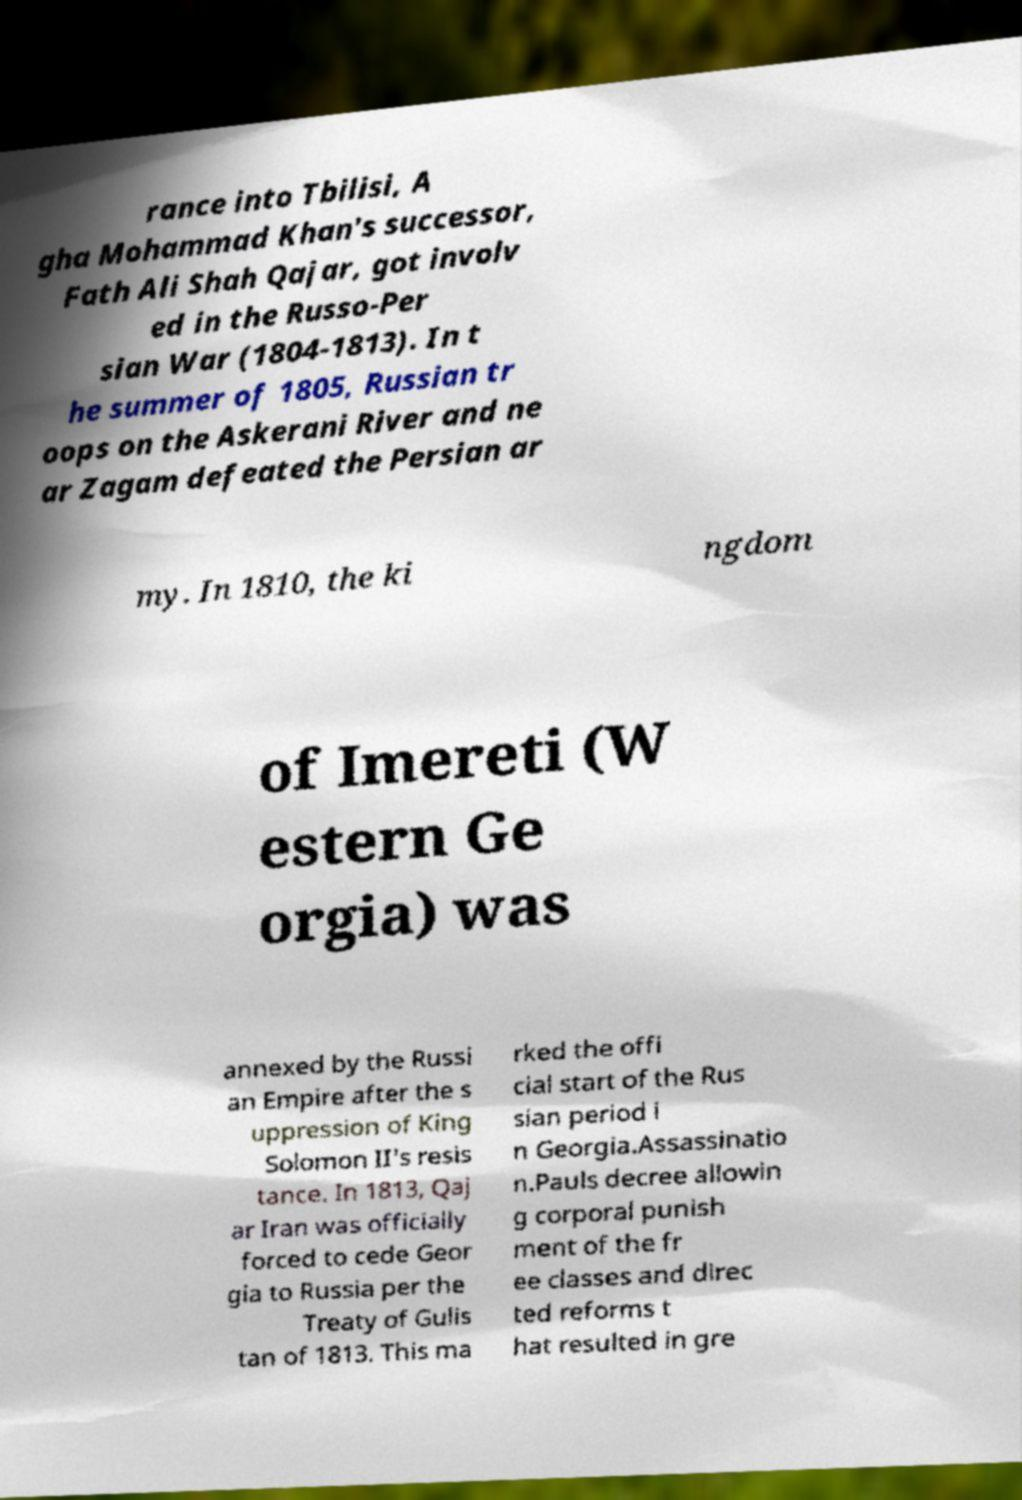Please identify and transcribe the text found in this image. rance into Tbilisi, A gha Mohammad Khan's successor, Fath Ali Shah Qajar, got involv ed in the Russo-Per sian War (1804-1813). In t he summer of 1805, Russian tr oops on the Askerani River and ne ar Zagam defeated the Persian ar my. In 1810, the ki ngdom of Imereti (W estern Ge orgia) was annexed by the Russi an Empire after the s uppression of King Solomon II's resis tance. In 1813, Qaj ar Iran was officially forced to cede Geor gia to Russia per the Treaty of Gulis tan of 1813. This ma rked the offi cial start of the Rus sian period i n Georgia.Assassinatio n.Pauls decree allowin g corporal punish ment of the fr ee classes and direc ted reforms t hat resulted in gre 